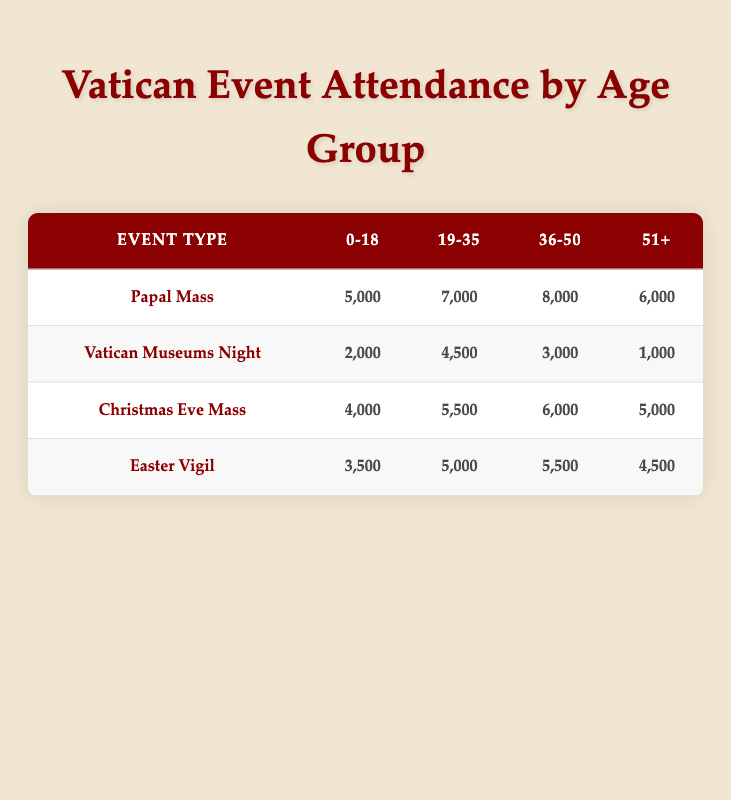What is the total attendance for Papal Mass? To find the total attendance for Papal Mass, I sum the attendances from all age groups: 5000 + 7000 + 8000 + 6000 = 26000.
Answer: 26000 Which age group had the highest attendance at Christmas Eve Mass? Looking at the attendance figures for Christmas Eve Mass, the age groups have 4000, 5500, 6000, and 5000, respectively. The highest value is 6000 for the age group 36-50.
Answer: 36-50 Is the attendance for Vatican Museums Night higher for the 19-35 age group compared to the 36-50 age group? The attendance for the 19-35 age group is 4500, and for the 36-50 age group, it is 3000. Since 4500 is greater than 3000, the statement is true.
Answer: Yes What is the average attendance for the 51+ age group across all events? To find the average attendance for the 51+ age group, I sum the attendances: 6000 (Papal Mass) + 1000 (Vatican Museums Night) + 5000 (Christmas Eve Mass) + 4500 (Easter Vigil) = 16500. Then I divide by 4 (the number of events) to get the average: 16500 / 4 = 4125.
Answer: 4125 Which event type had the lowest total attendance across all age groups? I calculate the total attendance for each event type: Papal Mass = 26000, Vatican Museums Night = 10500, Christmas Eve Mass = 21500, and Easter Vigil = 14500. The lowest total is for Vatican Museums Night at 10500.
Answer: Vatican Museums Night What percentage of the total attendance at Easter Vigil is from the age group 0-18? The total attendance for Easter Vigil is 3500 + 5000 + 5500 + 4500 = 19500. The attendance for the age group 0-18 is 3500. To calculate the percentage, we use (3500 / 19500) * 100 which equals approximately 17.95%.
Answer: Approximately 17.95% Does the attendance for age group 0-18 exceed 5000 for any event? Checking the attendance figures for age group 0-18: 5000 (Papal Mass), 2000 (Vatican Museums Night), 4000 (Christmas Eve Mass), and 3500 (Easter Vigil). Since none exceed 5000 apart from Papal Mass, the answer is no.
Answer: No What event had a higher attendance for the age group 19-35: Christmas Eve Mass or Easter Vigil? The attendance for 19-35 at Christmas Eve Mass is 5500, while for Easter Vigil, it is 5000. Since 5500 is greater than 5000, Christmas Eve Mass had higher attendance in this age group.
Answer: Christmas Eve Mass 